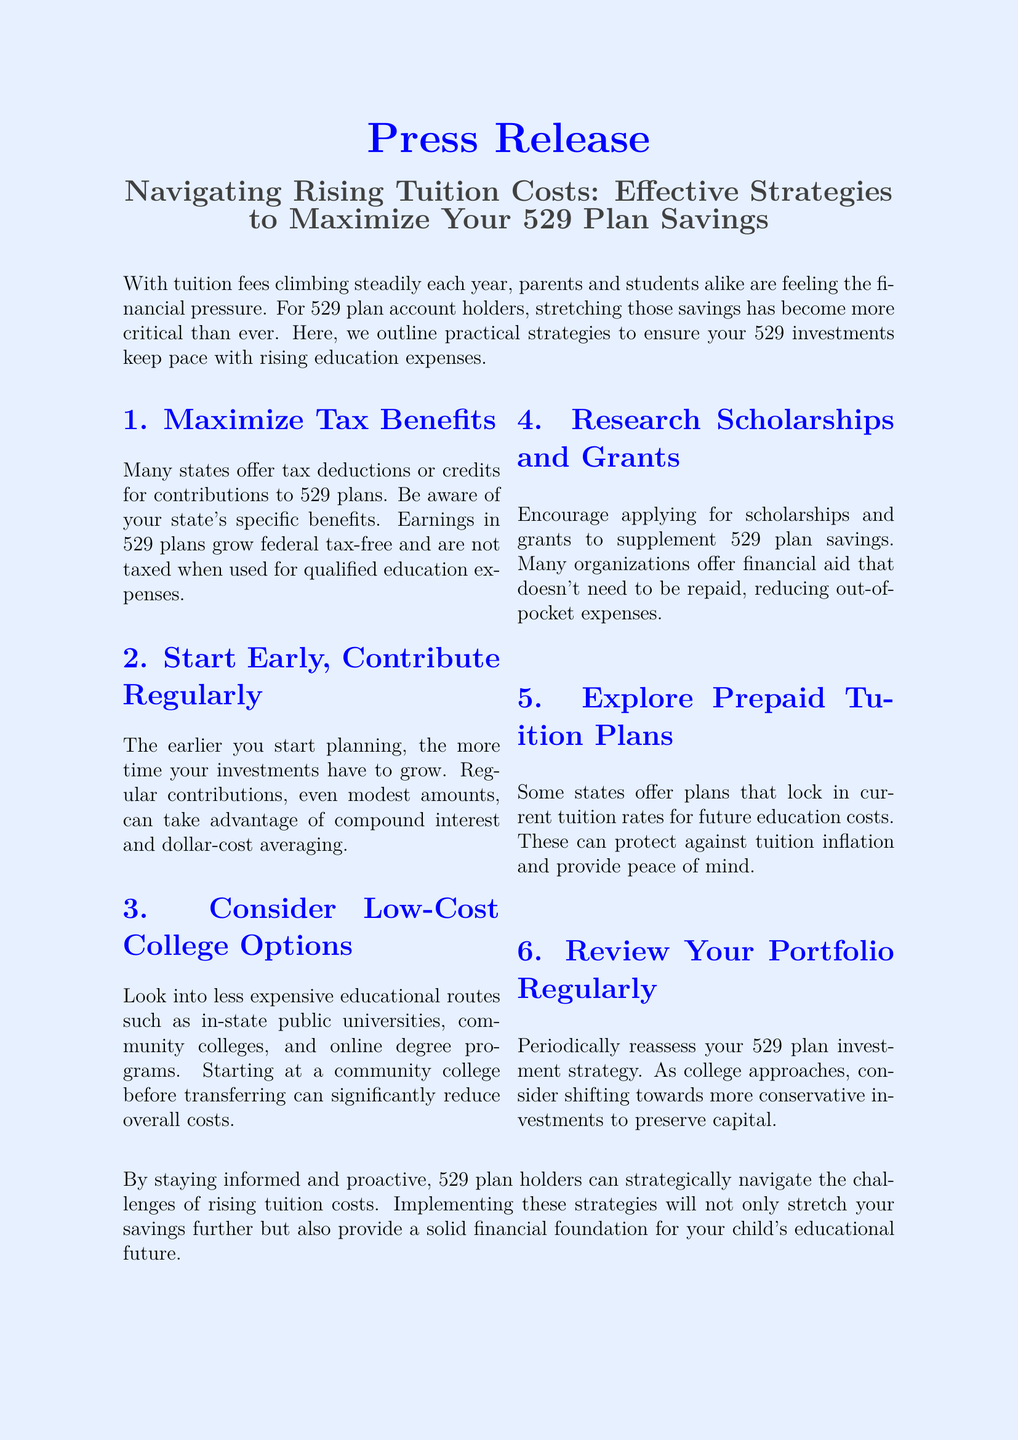What is the main topic of the press release? The document discusses strategies to manage the impact of rising tuition costs on 529 plan savings.
Answer: Strategies to maximize 529 plan savings What is one way to maximize tax benefits? The document states that many states offer tax deductions or credits for contributions to 529 plans.
Answer: Tax deductions or credits What should account holders do regularly according to the document? The press release suggests regularly reassessing your 529 plan investment strategy.
Answer: Review your portfolio What are prepaid tuition plans designed to do? Prepaid tuition plans lock in current tuition rates for future education costs.
Answer: Lock in tuition rates What is a suggested alternative to traditional universities to reduce costs? The document mentions considering community colleges and online degree programs.
Answer: Community colleges How does starting early help your 529 plan savings? The document indicates that starting early allows your investments more time to grow.
Answer: More time to grow What financial aid options does the document recommend researching? The press release advises looking for scholarships and grants to supplement savings.
Answer: Scholarships and grants What is a suggested benefit of community colleges according to the document? Starting at a community college before transferring can significantly reduce overall costs.
Answer: Significantly reduce overall costs 